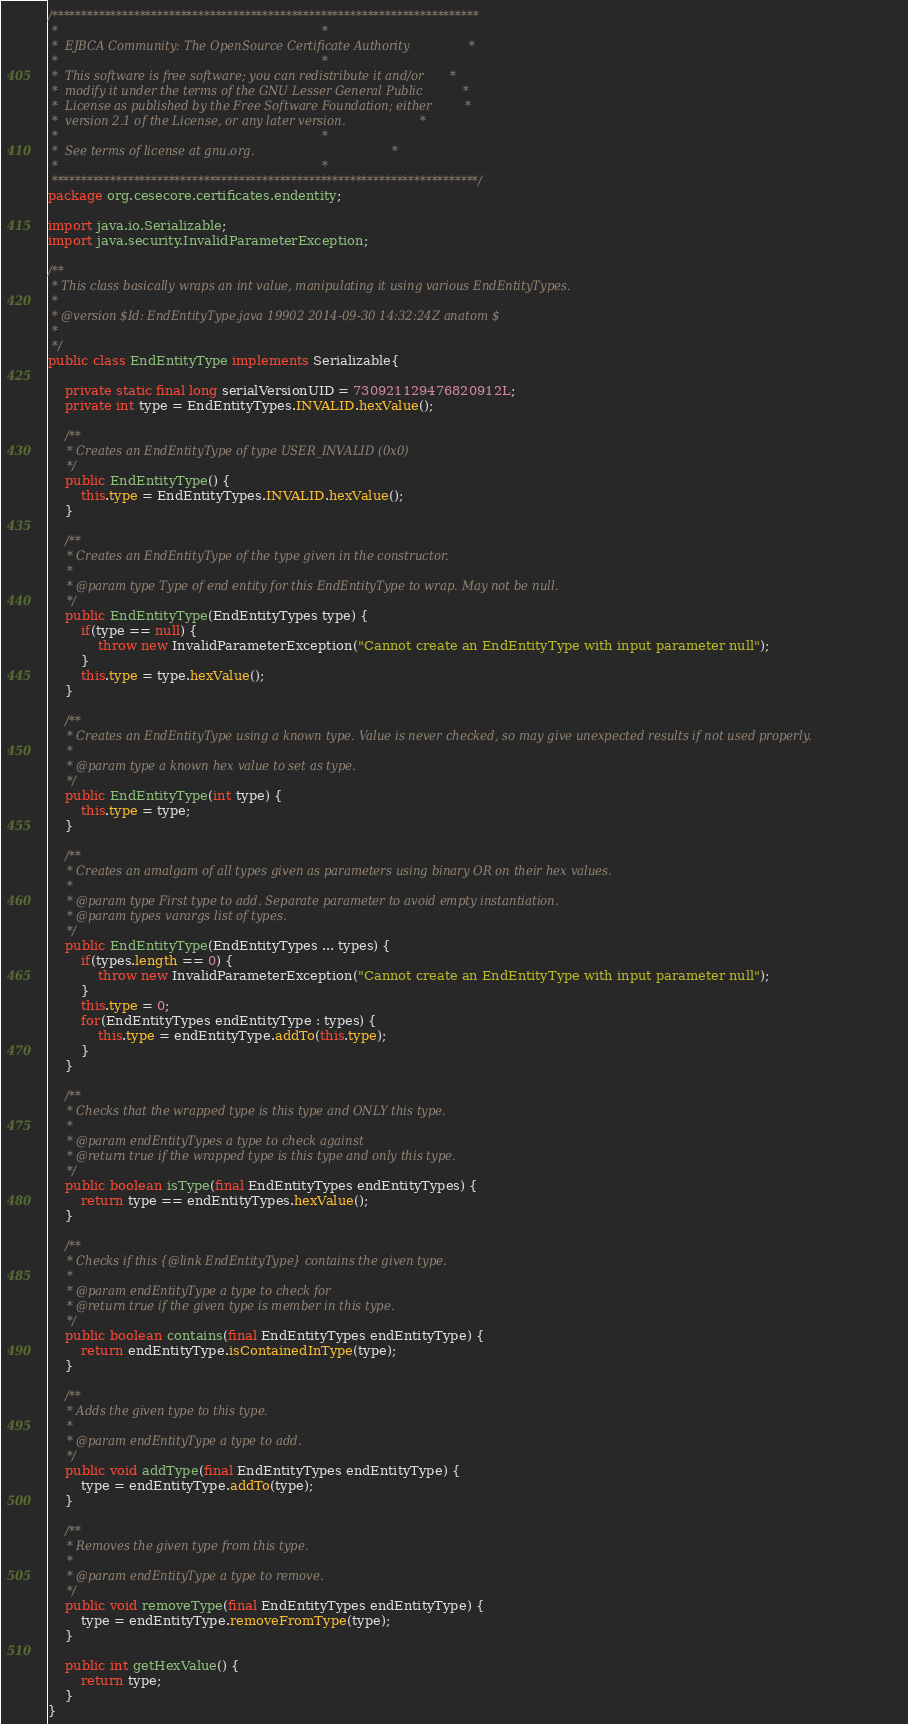<code> <loc_0><loc_0><loc_500><loc_500><_Java_>/*************************************************************************
 *                                                                       *
 *  EJBCA Community: The OpenSource Certificate Authority                *
 *                                                                       *
 *  This software is free software; you can redistribute it and/or       *
 *  modify it under the terms of the GNU Lesser General Public           *
 *  License as published by the Free Software Foundation; either         *
 *  version 2.1 of the License, or any later version.                    *
 *                                                                       *
 *  See terms of license at gnu.org.                                     *
 *                                                                       *
 *************************************************************************/
package org.cesecore.certificates.endentity;

import java.io.Serializable;
import java.security.InvalidParameterException;

/**
 * This class basically wraps an int value, manipulating it using various EndEntityTypes. 
 * 
 * @version $Id: EndEntityType.java 19902 2014-09-30 14:32:24Z anatom $
 *
 */
public class EndEntityType implements Serializable{

    private static final long serialVersionUID = 730921129476820912L;
    private int type = EndEntityTypes.INVALID.hexValue();
    
    /**
     * Creates an EndEntityType of type USER_INVALID (0x0)
     */
    public EndEntityType() {
        this.type = EndEntityTypes.INVALID.hexValue();
    }
    
    /**
     * Creates an EndEntityType of the type given in the constructor.
     * 
     * @param type Type of end entity for this EndEntityType to wrap. May not be null. 
     */
    public EndEntityType(EndEntityTypes type) {
        if(type == null) {
            throw new InvalidParameterException("Cannot create an EndEntityType with input parameter null");
        }
        this.type = type.hexValue();
    }
    
    /**
     * Creates an EndEntityType using a known type. Value is never checked, so may give unexpected results if not used properly. 
     * 
     * @param type a known hex value to set as type.
     */
    public EndEntityType(int type) {
        this.type = type;
    }
    
    /**
     * Creates an amalgam of all types given as parameters using binary OR on their hex values.   
     * 
     * @param type First type to add. Separate parameter to avoid empty instantiation. 
     * @param types varargs list of types. 
     */
    public EndEntityType(EndEntityTypes ... types) {
        if(types.length == 0) {
            throw new InvalidParameterException("Cannot create an EndEntityType with input parameter null");
        }
        this.type = 0;
        for(EndEntityTypes endEntityType : types) {
            this.type = endEntityType.addTo(this.type);
        }
    }
    
    /**
     * Checks that the wrapped type is this type and ONLY this type.
     * 
     * @param endEntityTypes a type to check against
     * @return true if the wrapped type is this type and only this type.
     */
    public boolean isType(final EndEntityTypes endEntityTypes) {
        return type == endEntityTypes.hexValue();
    }
    
    /**
     * Checks if this {@link EndEntityType} contains the given type. 
     * 
     * @param endEntityType a type to check for
     * @return true if the given type is member in this type.
     */
    public boolean contains(final EndEntityTypes endEntityType) {
        return endEntityType.isContainedInType(type);
    }
    
    /**
     * Adds the given type to this type.
     * 
     * @param endEntityType a type to add.
     */
    public void addType(final EndEntityTypes endEntityType) {
        type = endEntityType.addTo(type);
    }
    
    /**
     * Removes the given type from this type.
     * 
     * @param endEntityType a type to remove.
     */
    public void removeType(final EndEntityTypes endEntityType) {
        type = endEntityType.removeFromType(type);
    }
    
    public int getHexValue() {
        return type;
    }
}
</code> 